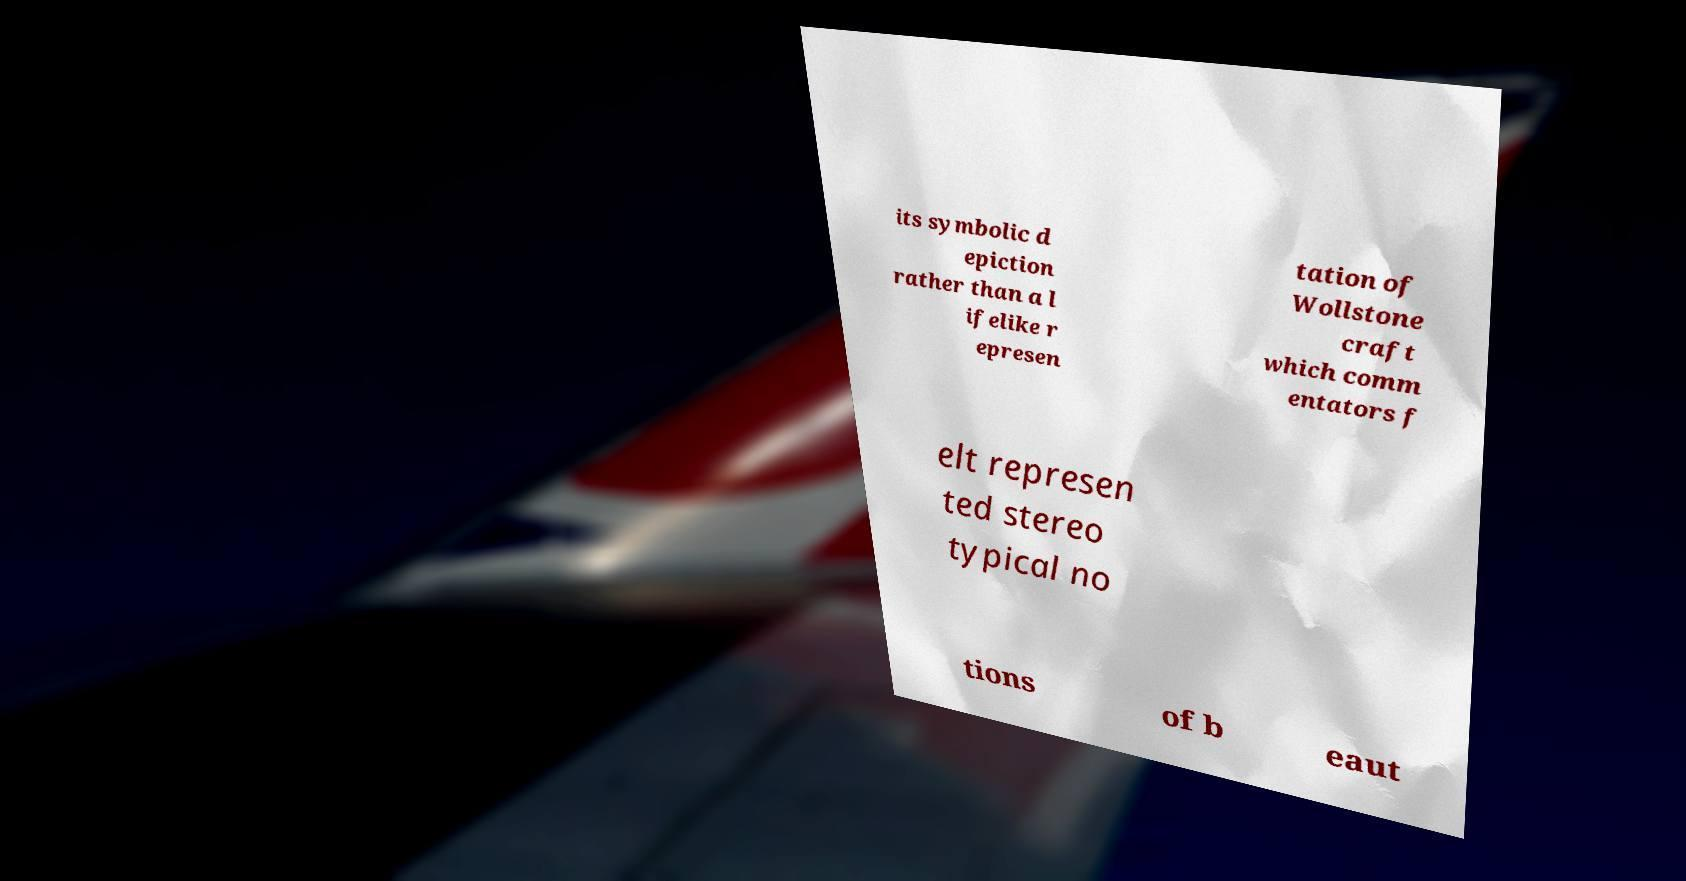Can you read and provide the text displayed in the image?This photo seems to have some interesting text. Can you extract and type it out for me? its symbolic d epiction rather than a l ifelike r epresen tation of Wollstone craft which comm entators f elt represen ted stereo typical no tions of b eaut 